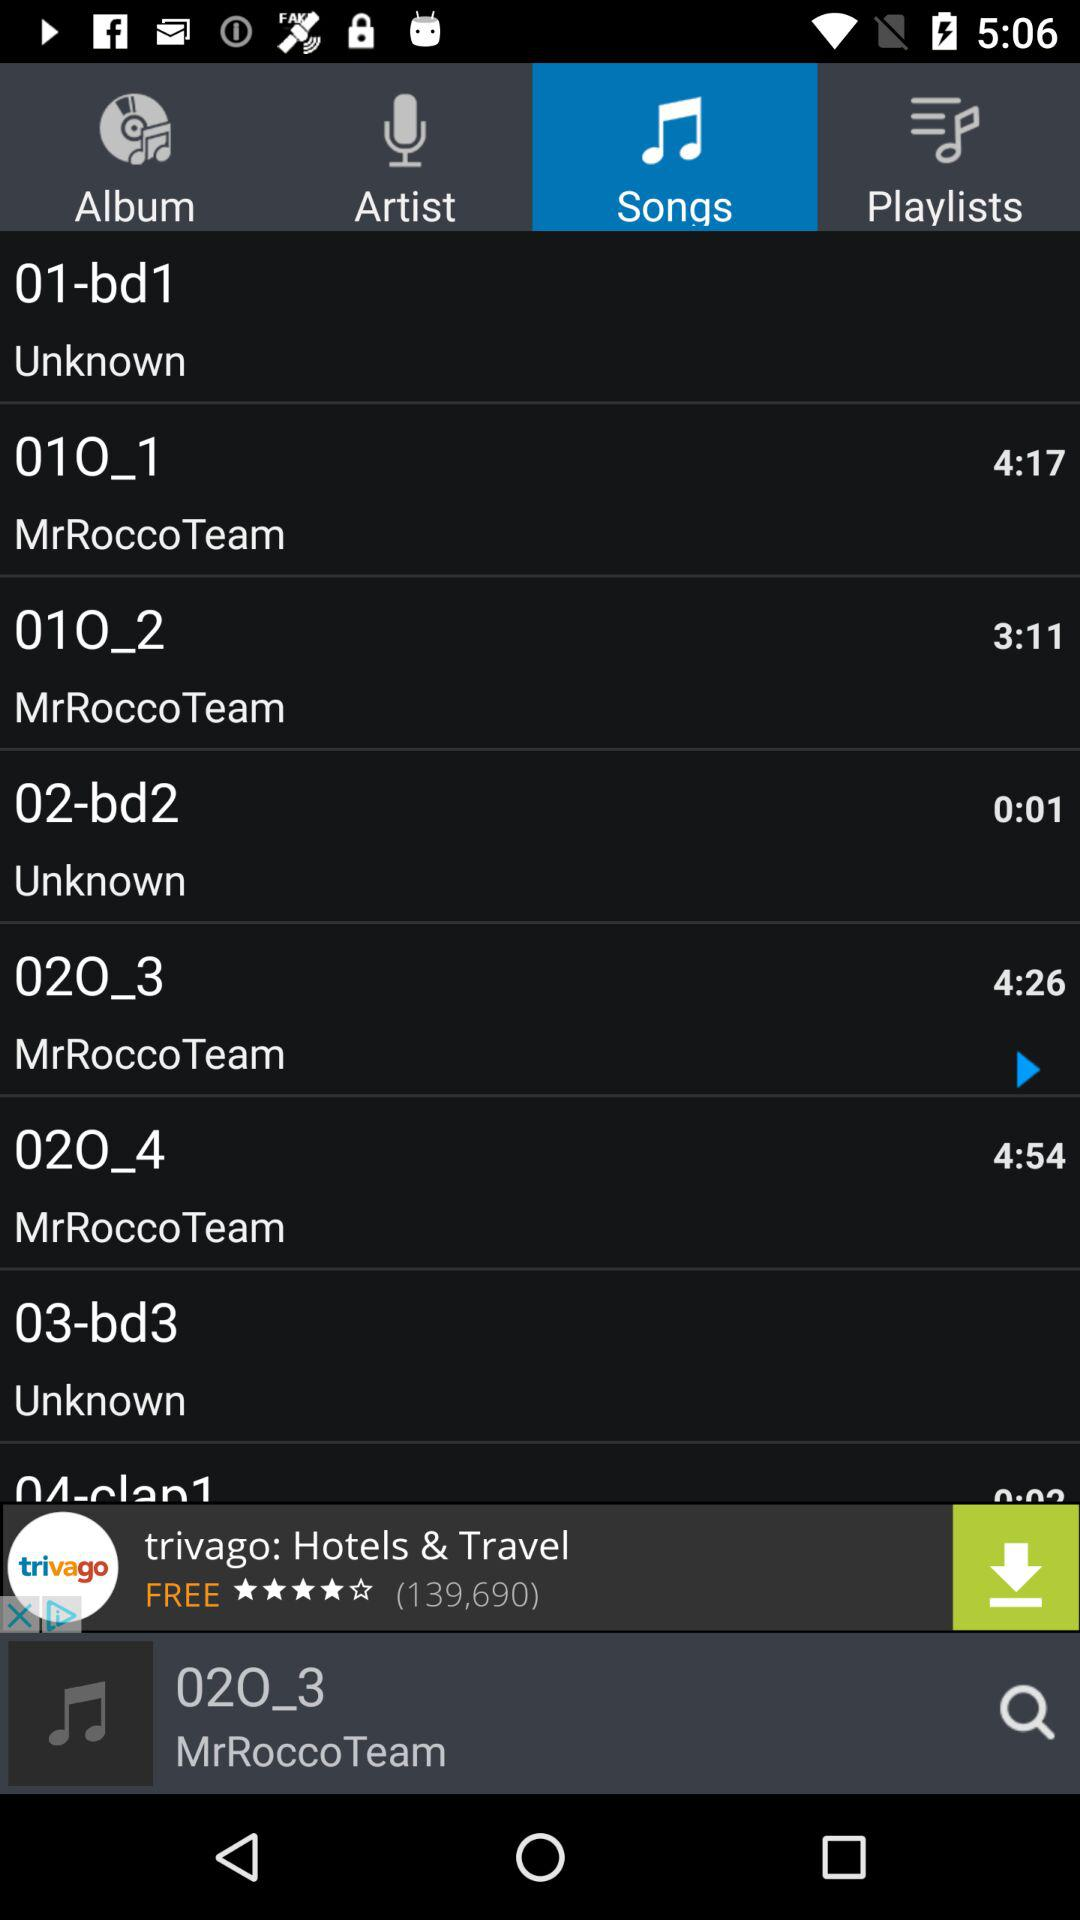What is the duration of the song "02O_4"? The duration of the song is 4 minutes 54 seconds. 